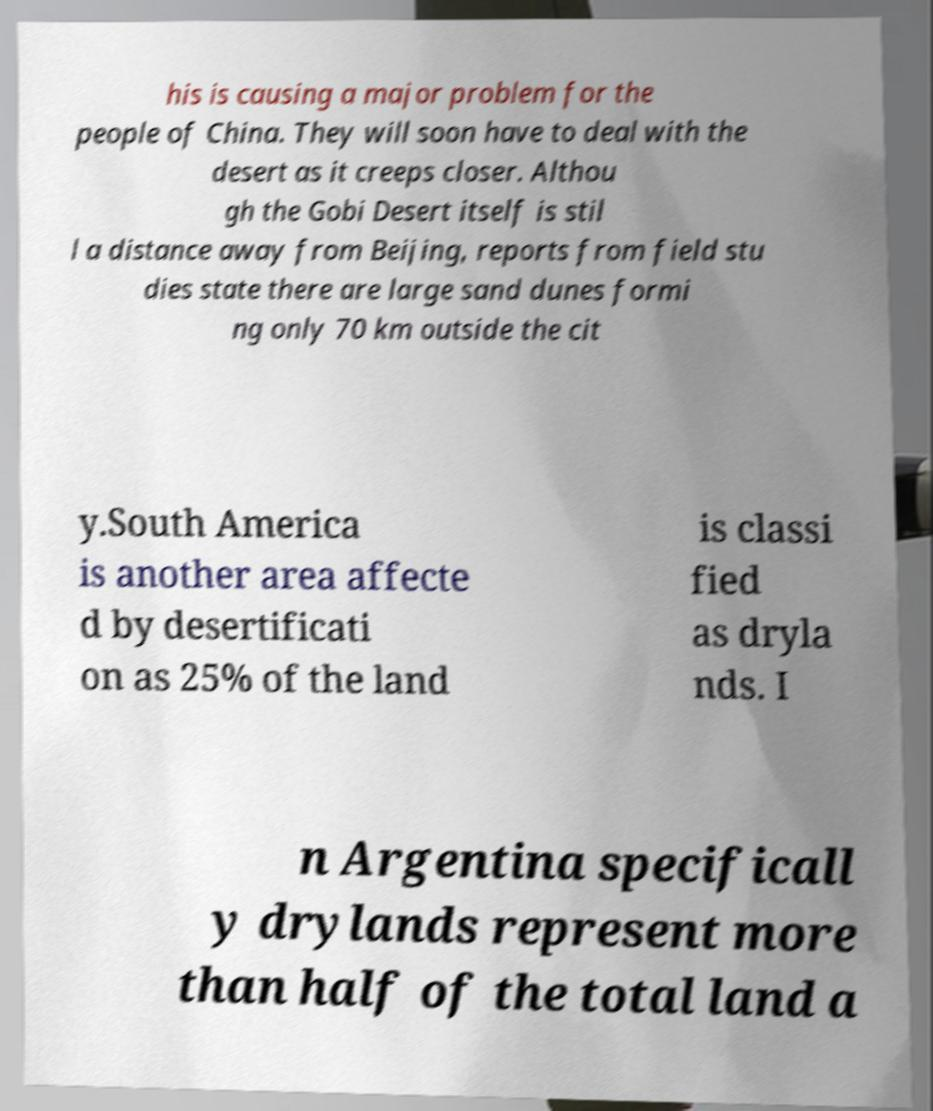Please identify and transcribe the text found in this image. his is causing a major problem for the people of China. They will soon have to deal with the desert as it creeps closer. Althou gh the Gobi Desert itself is stil l a distance away from Beijing, reports from field stu dies state there are large sand dunes formi ng only 70 km outside the cit y.South America is another area affecte d by desertificati on as 25% of the land is classi fied as dryla nds. I n Argentina specificall y drylands represent more than half of the total land a 